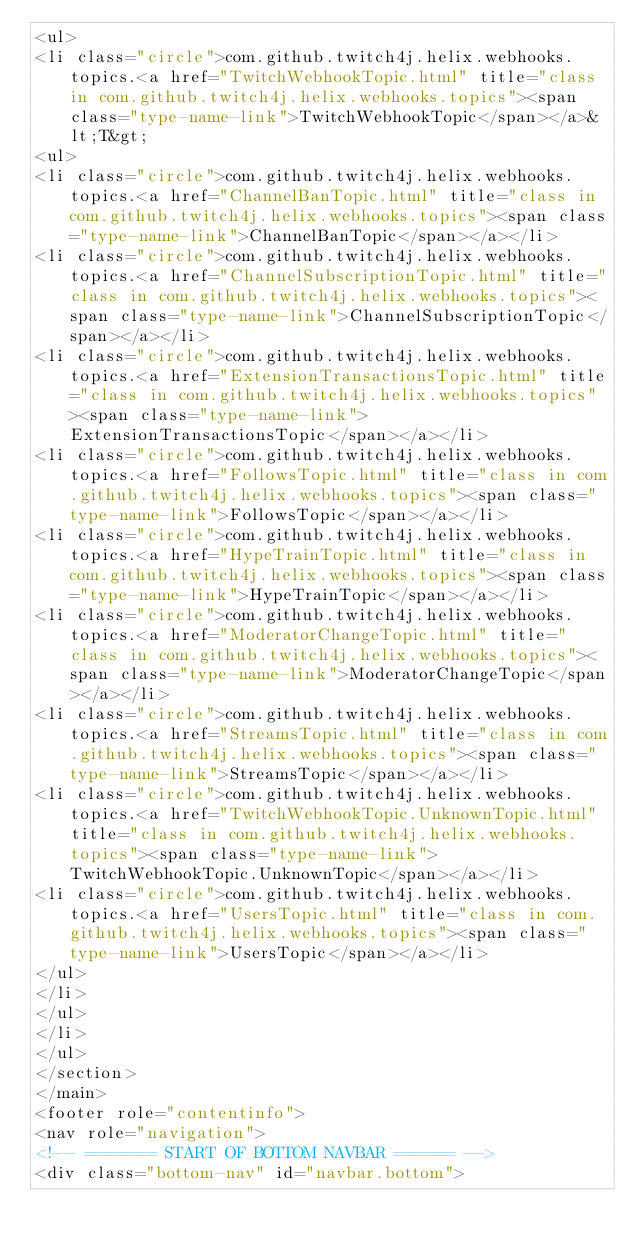<code> <loc_0><loc_0><loc_500><loc_500><_HTML_><ul>
<li class="circle">com.github.twitch4j.helix.webhooks.topics.<a href="TwitchWebhookTopic.html" title="class in com.github.twitch4j.helix.webhooks.topics"><span class="type-name-link">TwitchWebhookTopic</span></a>&lt;T&gt;
<ul>
<li class="circle">com.github.twitch4j.helix.webhooks.topics.<a href="ChannelBanTopic.html" title="class in com.github.twitch4j.helix.webhooks.topics"><span class="type-name-link">ChannelBanTopic</span></a></li>
<li class="circle">com.github.twitch4j.helix.webhooks.topics.<a href="ChannelSubscriptionTopic.html" title="class in com.github.twitch4j.helix.webhooks.topics"><span class="type-name-link">ChannelSubscriptionTopic</span></a></li>
<li class="circle">com.github.twitch4j.helix.webhooks.topics.<a href="ExtensionTransactionsTopic.html" title="class in com.github.twitch4j.helix.webhooks.topics"><span class="type-name-link">ExtensionTransactionsTopic</span></a></li>
<li class="circle">com.github.twitch4j.helix.webhooks.topics.<a href="FollowsTopic.html" title="class in com.github.twitch4j.helix.webhooks.topics"><span class="type-name-link">FollowsTopic</span></a></li>
<li class="circle">com.github.twitch4j.helix.webhooks.topics.<a href="HypeTrainTopic.html" title="class in com.github.twitch4j.helix.webhooks.topics"><span class="type-name-link">HypeTrainTopic</span></a></li>
<li class="circle">com.github.twitch4j.helix.webhooks.topics.<a href="ModeratorChangeTopic.html" title="class in com.github.twitch4j.helix.webhooks.topics"><span class="type-name-link">ModeratorChangeTopic</span></a></li>
<li class="circle">com.github.twitch4j.helix.webhooks.topics.<a href="StreamsTopic.html" title="class in com.github.twitch4j.helix.webhooks.topics"><span class="type-name-link">StreamsTopic</span></a></li>
<li class="circle">com.github.twitch4j.helix.webhooks.topics.<a href="TwitchWebhookTopic.UnknownTopic.html" title="class in com.github.twitch4j.helix.webhooks.topics"><span class="type-name-link">TwitchWebhookTopic.UnknownTopic</span></a></li>
<li class="circle">com.github.twitch4j.helix.webhooks.topics.<a href="UsersTopic.html" title="class in com.github.twitch4j.helix.webhooks.topics"><span class="type-name-link">UsersTopic</span></a></li>
</ul>
</li>
</ul>
</li>
</ul>
</section>
</main>
<footer role="contentinfo">
<nav role="navigation">
<!-- ======= START OF BOTTOM NAVBAR ====== -->
<div class="bottom-nav" id="navbar.bottom"></code> 